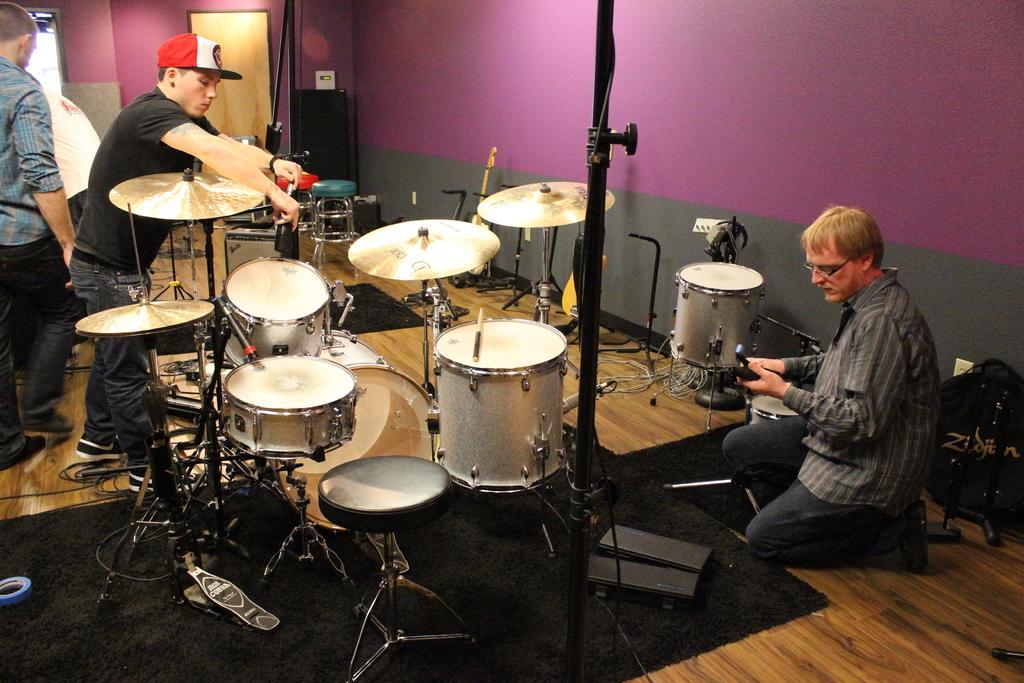Describe this image in one or two sentences. In this image we can see a man sitting on his knees on the floor holding an object and some people standing on the floor. We can also see some musical instruments with the stands, a stool, a tape, wires and some objects on the floor. On the backside we can see a speaker box and a door. 